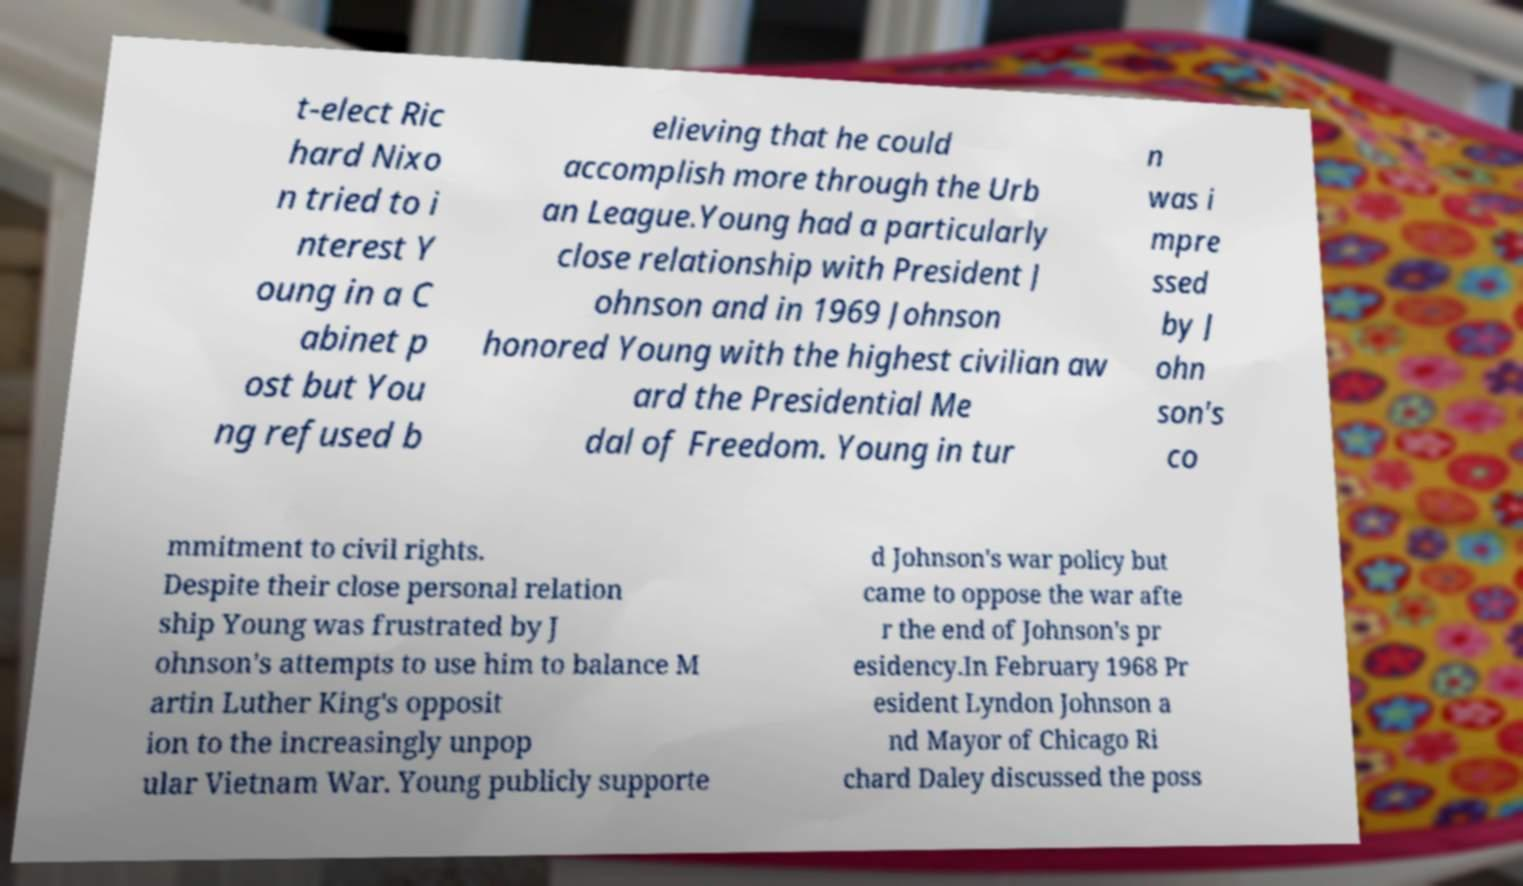Could you extract and type out the text from this image? t-elect Ric hard Nixo n tried to i nterest Y oung in a C abinet p ost but You ng refused b elieving that he could accomplish more through the Urb an League.Young had a particularly close relationship with President J ohnson and in 1969 Johnson honored Young with the highest civilian aw ard the Presidential Me dal of Freedom. Young in tur n was i mpre ssed by J ohn son's co mmitment to civil rights. Despite their close personal relation ship Young was frustrated by J ohnson's attempts to use him to balance M artin Luther King's opposit ion to the increasingly unpop ular Vietnam War. Young publicly supporte d Johnson's war policy but came to oppose the war afte r the end of Johnson's pr esidency.In February 1968 Pr esident Lyndon Johnson a nd Mayor of Chicago Ri chard Daley discussed the poss 